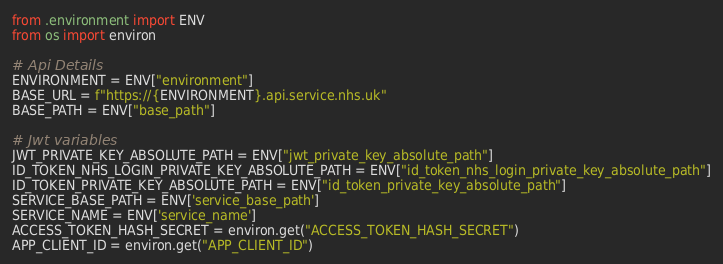Convert code to text. <code><loc_0><loc_0><loc_500><loc_500><_Python_>from .environment import ENV
from os import environ

# Api Details
ENVIRONMENT = ENV["environment"]
BASE_URL = f"https://{ENVIRONMENT}.api.service.nhs.uk"
BASE_PATH = ENV["base_path"]

# Jwt variables
JWT_PRIVATE_KEY_ABSOLUTE_PATH = ENV["jwt_private_key_absolute_path"]
ID_TOKEN_NHS_LOGIN_PRIVATE_KEY_ABSOLUTE_PATH = ENV["id_token_nhs_login_private_key_absolute_path"]
ID_TOKEN_PRIVATE_KEY_ABSOLUTE_PATH = ENV["id_token_private_key_absolute_path"]
SERVICE_BASE_PATH = ENV['service_base_path']
SERVICE_NAME = ENV['service_name']
ACCESS_TOKEN_HASH_SECRET = environ.get("ACCESS_TOKEN_HASH_SECRET")
APP_CLIENT_ID = environ.get("APP_CLIENT_ID")
</code> 